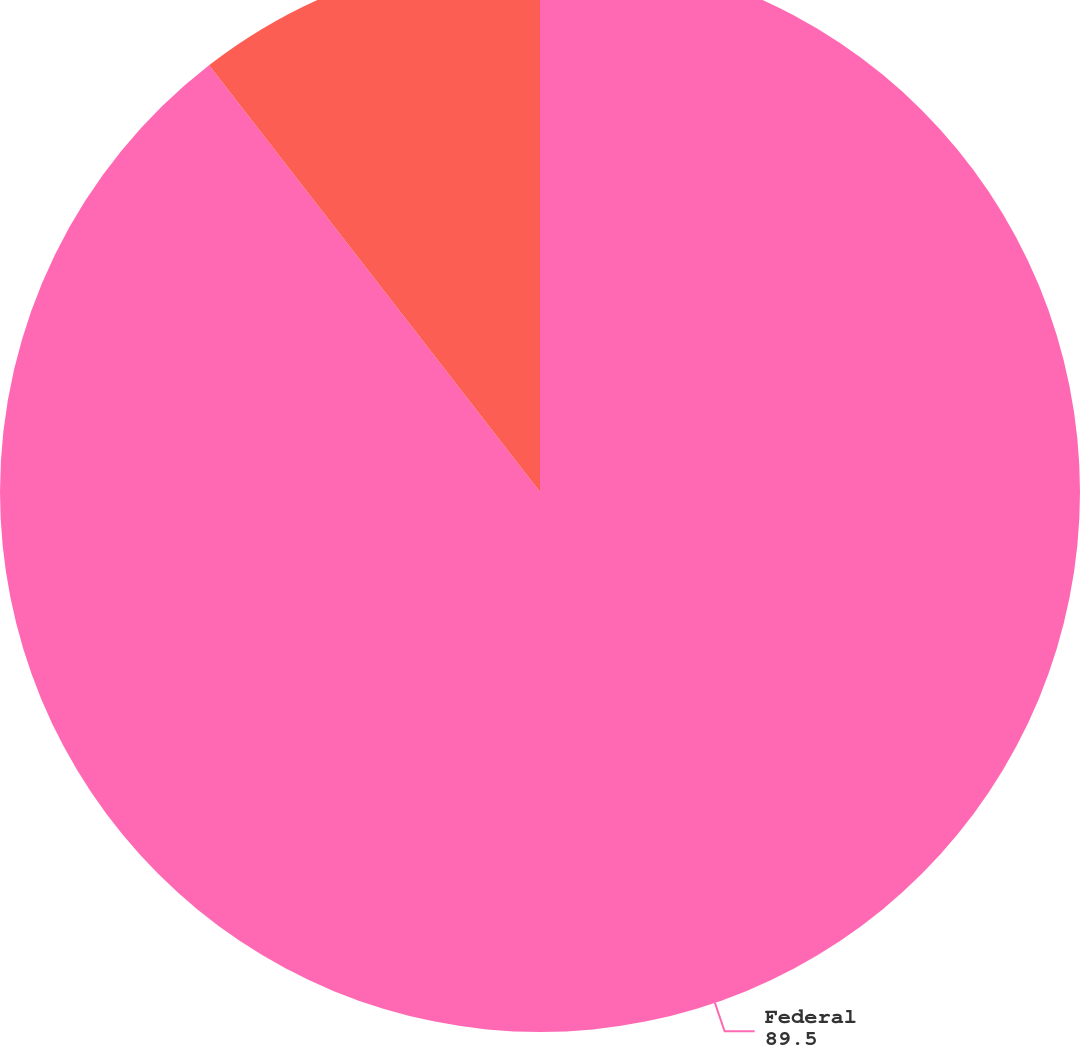<chart> <loc_0><loc_0><loc_500><loc_500><pie_chart><fcel>Federal<fcel>State<nl><fcel>89.5%<fcel>10.5%<nl></chart> 